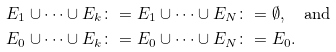Convert formula to latex. <formula><loc_0><loc_0><loc_500><loc_500>E _ { 1 } \cup \cdots \cup E _ { k } & \colon = E _ { 1 } \cup \cdots \cup E _ { N } \colon = \emptyset , \quad \text {and} \\ E _ { 0 } \cup \cdots \cup E _ { k } & \colon = E _ { 0 } \cup \cdots \cup E _ { N } \colon = E _ { 0 } .</formula> 